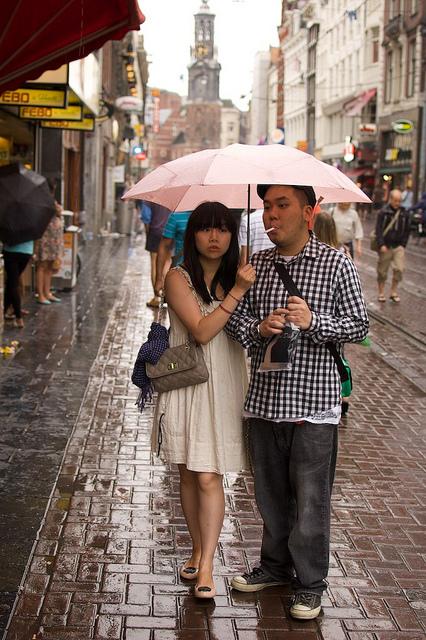Do these two people look to be in love?
Quick response, please. Yes. Is the man chivalrous?
Be succinct. No. What color is the umbrella?
Give a very brief answer. Pink. What doe the colors in the umbrella symbolize?
Give a very brief answer. Love. 